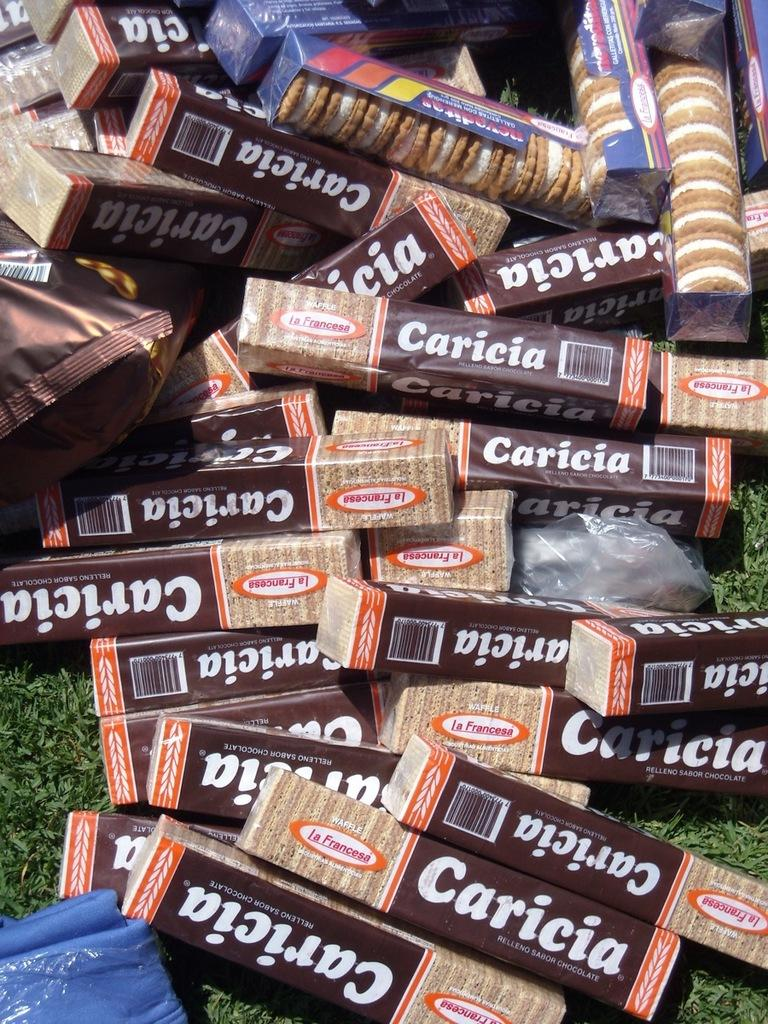What type of food is visible in the boxes in the image? There are cream biscuits in the boxes in the image. Where are the packets located in the image? The packets are on the grass in the image. How many ladybugs can be seen crawling on the can in the image? There are no cans or ladybugs present in the image. 